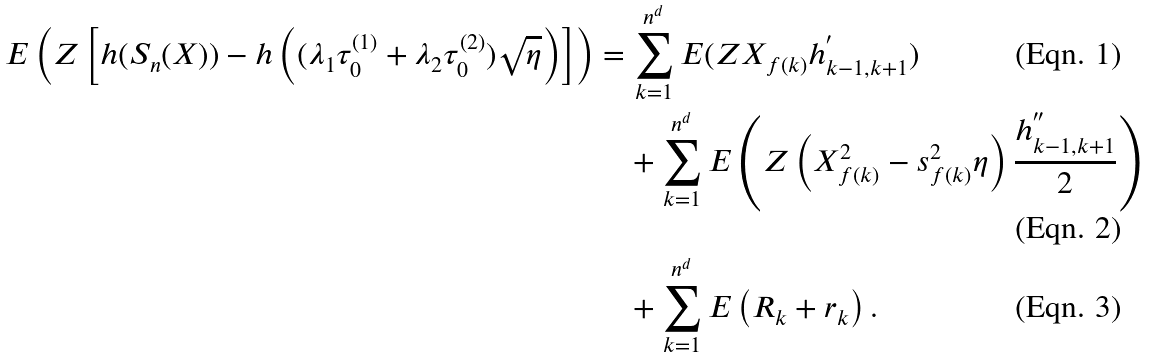Convert formula to latex. <formula><loc_0><loc_0><loc_500><loc_500>E \left ( Z \left [ h ( S _ { n } ( X ) ) - h \left ( ( \lambda _ { 1 } \tau _ { 0 } ^ { ( 1 ) } + \lambda _ { 2 } \tau _ { 0 } ^ { ( 2 ) } ) \sqrt { \eta } \right ) \right ] \right ) & = \sum _ { k = 1 } ^ { n ^ { d } } E ( Z X _ { f ( k ) } h _ { k - 1 , k + 1 } ^ { ^ { \prime } } ) \\ & \quad + \sum _ { k = 1 } ^ { n ^ { d } } E \left ( Z \left ( X _ { f ( k ) } ^ { 2 } - s _ { f ( k ) } ^ { 2 } \eta \right ) \frac { h _ { k - 1 , k + 1 } ^ { ^ { \prime \prime } } } { 2 } \right ) \\ & \quad + \sum _ { k = 1 } ^ { n ^ { d } } E \left ( R _ { k } + r _ { k } \right ) .</formula> 